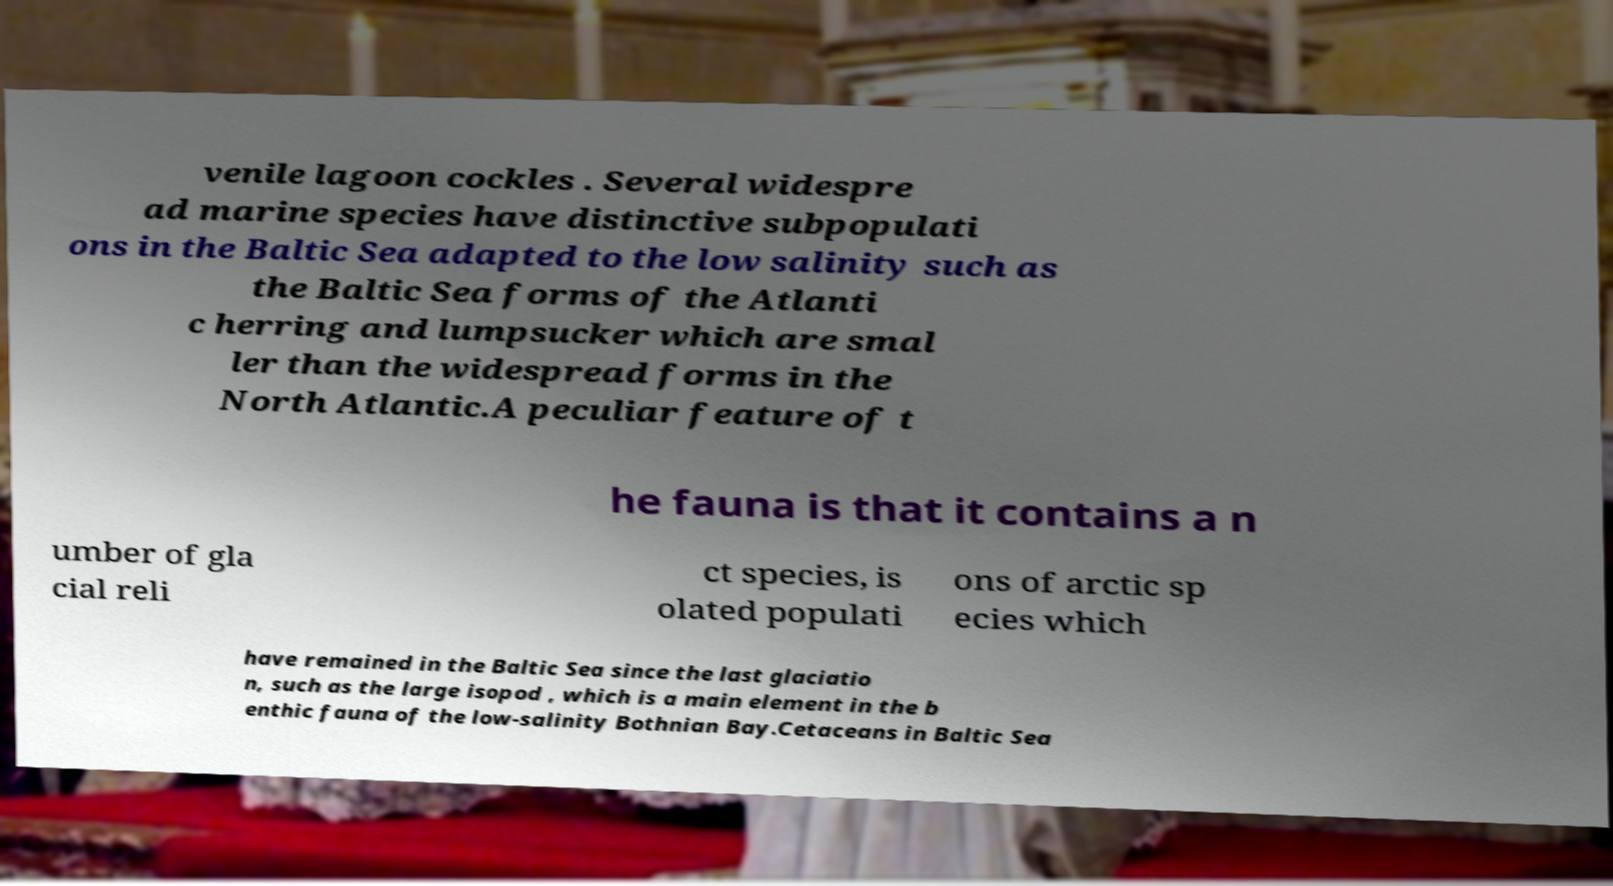Could you extract and type out the text from this image? venile lagoon cockles . Several widespre ad marine species have distinctive subpopulati ons in the Baltic Sea adapted to the low salinity such as the Baltic Sea forms of the Atlanti c herring and lumpsucker which are smal ler than the widespread forms in the North Atlantic.A peculiar feature of t he fauna is that it contains a n umber of gla cial reli ct species, is olated populati ons of arctic sp ecies which have remained in the Baltic Sea since the last glaciatio n, such as the large isopod , which is a main element in the b enthic fauna of the low-salinity Bothnian Bay.Cetaceans in Baltic Sea 